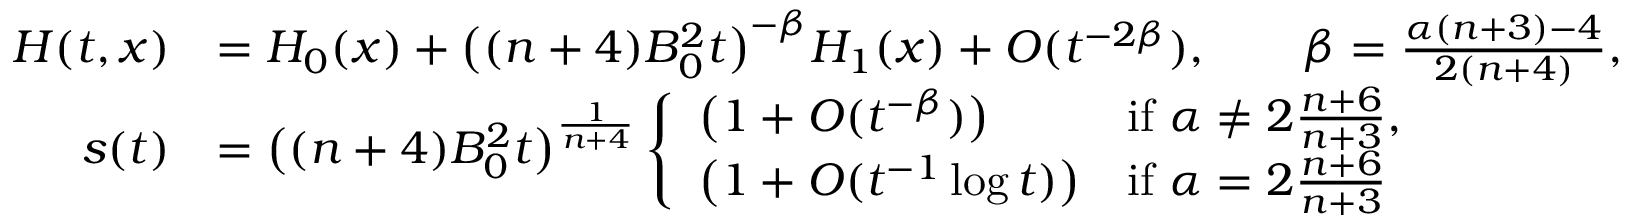Convert formula to latex. <formula><loc_0><loc_0><loc_500><loc_500>\begin{array} { r l } { H ( t , x ) } & { = H _ { 0 } ( x ) + \left ( ( n + 4 ) B _ { 0 } ^ { 2 } t \right ) ^ { - \beta } H _ { 1 } ( x ) + O ( t ^ { - 2 \beta } ) , \quad \beta = \frac { \alpha ( n + 3 ) - 4 } { 2 ( n + 4 ) } , } \\ { s ( t ) } & { = \left ( ( n + 4 ) B _ { 0 } ^ { 2 } t \right ) ^ { \frac { 1 } { n + 4 } } \left \{ \begin{array} { l l } { \left ( 1 + O ( t ^ { - \beta } ) \right ) } & { i f \alpha \ne 2 \frac { n + 6 } { n + 3 } , } \\ { \left ( 1 + O ( t ^ { - 1 } \log t ) \right ) } & { i f \alpha = 2 \frac { n + 6 } { n + 3 } } \end{array} } \end{array}</formula> 